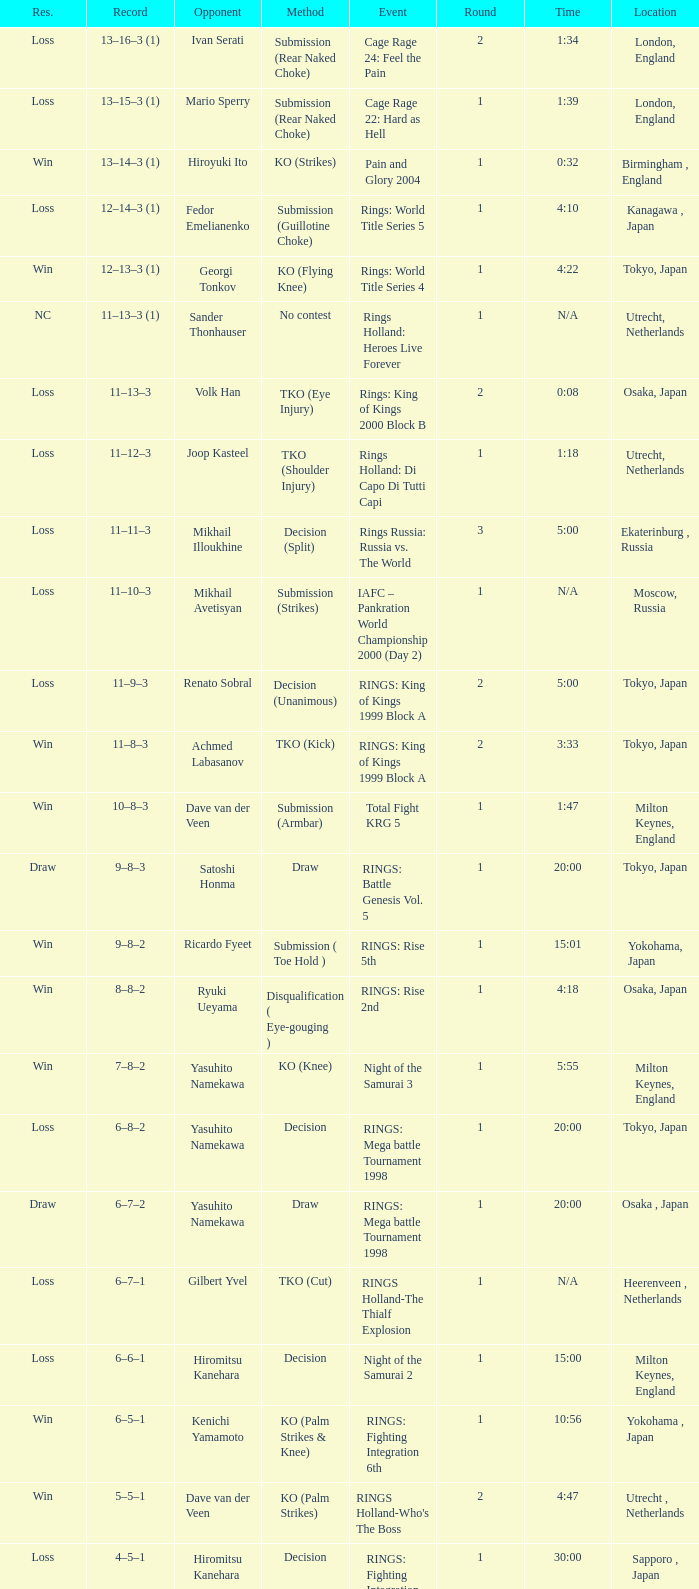Would you mind parsing the complete table? {'header': ['Res.', 'Record', 'Opponent', 'Method', 'Event', 'Round', 'Time', 'Location'], 'rows': [['Loss', '13–16–3 (1)', 'Ivan Serati', 'Submission (Rear Naked Choke)', 'Cage Rage 24: Feel the Pain', '2', '1:34', 'London, England'], ['Loss', '13–15–3 (1)', 'Mario Sperry', 'Submission (Rear Naked Choke)', 'Cage Rage 22: Hard as Hell', '1', '1:39', 'London, England'], ['Win', '13–14–3 (1)', 'Hiroyuki Ito', 'KO (Strikes)', 'Pain and Glory 2004', '1', '0:32', 'Birmingham , England'], ['Loss', '12–14–3 (1)', 'Fedor Emelianenko', 'Submission (Guillotine Choke)', 'Rings: World Title Series 5', '1', '4:10', 'Kanagawa , Japan'], ['Win', '12–13–3 (1)', 'Georgi Tonkov', 'KO (Flying Knee)', 'Rings: World Title Series 4', '1', '4:22', 'Tokyo, Japan'], ['NC', '11–13–3 (1)', 'Sander Thonhauser', 'No contest', 'Rings Holland: Heroes Live Forever', '1', 'N/A', 'Utrecht, Netherlands'], ['Loss', '11–13–3', 'Volk Han', 'TKO (Eye Injury)', 'Rings: King of Kings 2000 Block B', '2', '0:08', 'Osaka, Japan'], ['Loss', '11–12–3', 'Joop Kasteel', 'TKO (Shoulder Injury)', 'Rings Holland: Di Capo Di Tutti Capi', '1', '1:18', 'Utrecht, Netherlands'], ['Loss', '11–11–3', 'Mikhail Illoukhine', 'Decision (Split)', 'Rings Russia: Russia vs. The World', '3', '5:00', 'Ekaterinburg , Russia'], ['Loss', '11–10–3', 'Mikhail Avetisyan', 'Submission (Strikes)', 'IAFC – Pankration World Championship 2000 (Day 2)', '1', 'N/A', 'Moscow, Russia'], ['Loss', '11–9–3', 'Renato Sobral', 'Decision (Unanimous)', 'RINGS: King of Kings 1999 Block A', '2', '5:00', 'Tokyo, Japan'], ['Win', '11–8–3', 'Achmed Labasanov', 'TKO (Kick)', 'RINGS: King of Kings 1999 Block A', '2', '3:33', 'Tokyo, Japan'], ['Win', '10–8–3', 'Dave van der Veen', 'Submission (Armbar)', 'Total Fight KRG 5', '1', '1:47', 'Milton Keynes, England'], ['Draw', '9–8–3', 'Satoshi Honma', 'Draw', 'RINGS: Battle Genesis Vol. 5', '1', '20:00', 'Tokyo, Japan'], ['Win', '9–8–2', 'Ricardo Fyeet', 'Submission ( Toe Hold )', 'RINGS: Rise 5th', '1', '15:01', 'Yokohama, Japan'], ['Win', '8–8–2', 'Ryuki Ueyama', 'Disqualification ( Eye-gouging )', 'RINGS: Rise 2nd', '1', '4:18', 'Osaka, Japan'], ['Win', '7–8–2', 'Yasuhito Namekawa', 'KO (Knee)', 'Night of the Samurai 3', '1', '5:55', 'Milton Keynes, England'], ['Loss', '6–8–2', 'Yasuhito Namekawa', 'Decision', 'RINGS: Mega battle Tournament 1998', '1', '20:00', 'Tokyo, Japan'], ['Draw', '6–7–2', 'Yasuhito Namekawa', 'Draw', 'RINGS: Mega battle Tournament 1998', '1', '20:00', 'Osaka , Japan'], ['Loss', '6–7–1', 'Gilbert Yvel', 'TKO (Cut)', 'RINGS Holland-The Thialf Explosion', '1', 'N/A', 'Heerenveen , Netherlands'], ['Loss', '6–6–1', 'Hiromitsu Kanehara', 'Decision', 'Night of the Samurai 2', '1', '15:00', 'Milton Keynes, England'], ['Win', '6–5–1', 'Kenichi Yamamoto', 'KO (Palm Strikes & Knee)', 'RINGS: Fighting Integration 6th', '1', '10:56', 'Yokohama , Japan'], ['Win', '5–5–1', 'Dave van der Veen', 'KO (Palm Strikes)', "RINGS Holland-Who's The Boss", '2', '4:47', 'Utrecht , Netherlands'], ['Loss', '4–5–1', 'Hiromitsu Kanehara', 'Decision', 'RINGS: Fighting Integration 3rd', '1', '30:00', 'Sapporo , Japan'], ['Win', '4–4–1', 'Sander Thonhauser', 'Submission ( Armbar )', 'Night of the Samurai 1', '1', '0:55', 'Milton Keynes, England'], ['Loss', '3–4–1', 'Joop Kasteel', 'Submission ( Headlock )', 'RINGS: Mega Battle Tournament 1997', '1', '8:55', 'Tokyo, Japan'], ['Win', '3–3–1', 'Peter Dijkman', 'Submission ( Rear Naked Choke )', 'Total Fight Night', '1', '4:46', 'Milton Keynes, England'], ['Loss', '2–3–1', 'Masayuki Naruse', 'Submission ( Shoulder Necklock )', 'RINGS: Fighting Extension Vol. 4', '1', '12:58', 'Tokyo, Japan'], ['Win', '2–2–1', 'Sean McCully', 'Submission (Guillotine Choke)', 'RINGS: Battle Genesis Vol. 1', '1', '3:59', 'Tokyo, Japan'], ['Loss', '1–2–1', 'Hans Nijman', 'Submission ( Guillotine Choke )', 'RINGS Holland-The Final Challenge', '2', '0:51', 'Amsterdam, Netherlands'], ['Loss', '1–1–1', 'Cees Bezems', 'TKO (Cut)', 'IMA – Battle of Styles', '1', 'N/A', 'Amsterdam, Netherlands'], ['Draw', '1–0–1', 'Andre Mannaart', 'Draw', 'RINGS Holland-Kings of Martial Arts', '2', '5:00', 'Amsterdam , Netherlands'], ['Win', '1–0–0', 'Boston Jones', 'TKO (Cut)', 'Fighting Arts Gala', '2', '2:30', 'Milton Keynes , England']]} What was the method for opponent of Ivan Serati? Submission (Rear Naked Choke). 